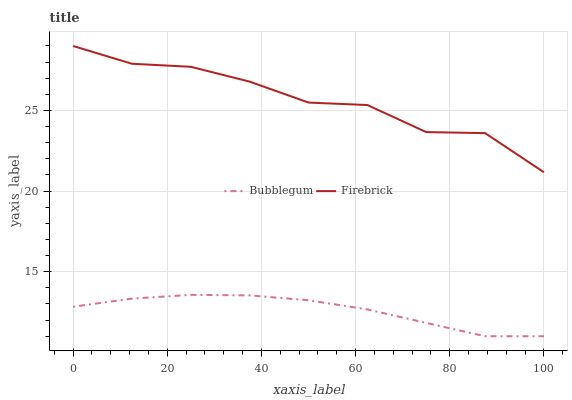Does Bubblegum have the maximum area under the curve?
Answer yes or no. No. Is Bubblegum the roughest?
Answer yes or no. No. Does Bubblegum have the highest value?
Answer yes or no. No. Is Bubblegum less than Firebrick?
Answer yes or no. Yes. Is Firebrick greater than Bubblegum?
Answer yes or no. Yes. Does Bubblegum intersect Firebrick?
Answer yes or no. No. 